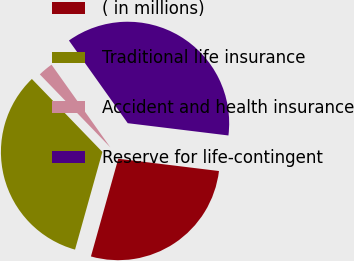Convert chart to OTSL. <chart><loc_0><loc_0><loc_500><loc_500><pie_chart><fcel>( in millions)<fcel>Traditional life insurance<fcel>Accident and health insurance<fcel>Reserve for life-contingent<nl><fcel>27.41%<fcel>33.43%<fcel>2.39%<fcel>36.77%<nl></chart> 